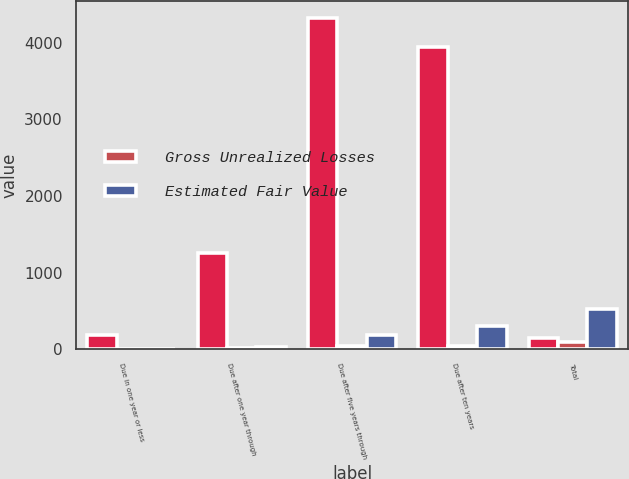Convert chart to OTSL. <chart><loc_0><loc_0><loc_500><loc_500><stacked_bar_chart><ecel><fcel>Due in one year or less<fcel>Due after one year through<fcel>Due after five years through<fcel>Due after ten years<fcel>Total<nl><fcel>nan<fcel>186<fcel>1252<fcel>4326<fcel>3949<fcel>143<nl><fcel>Gross Unrealized Losses<fcel>1.9<fcel>12.9<fcel>44.5<fcel>40.7<fcel>100<nl><fcel>Estimated Fair Value<fcel>2<fcel>32<fcel>186<fcel>308<fcel>528<nl></chart> 